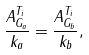Convert formula to latex. <formula><loc_0><loc_0><loc_500><loc_500>\frac { A ^ { T _ { i } } _ { G _ { a } } } { k _ { a } } = \frac { A ^ { T _ { i } } _ { G _ { b } } } { k _ { b } } ,</formula> 